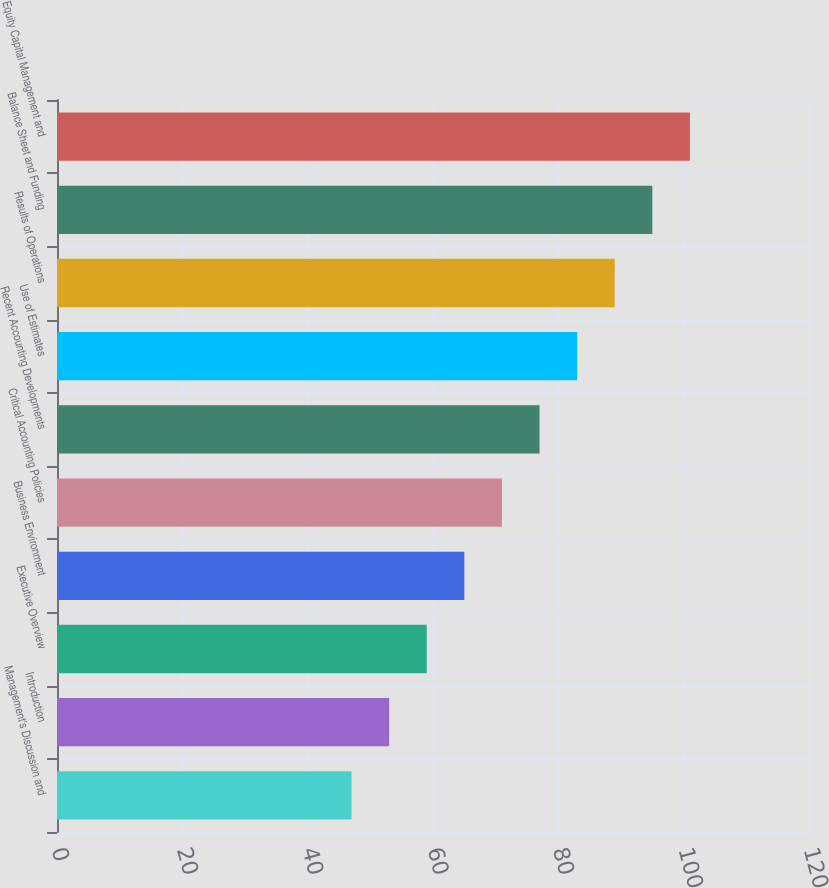<chart> <loc_0><loc_0><loc_500><loc_500><bar_chart><fcel>Management's Discussion and<fcel>Introduction<fcel>Executive Overview<fcel>Business Environment<fcel>Critical Accounting Policies<fcel>Recent Accounting Developments<fcel>Use of Estimates<fcel>Results of Operations<fcel>Balance Sheet and Funding<fcel>Equity Capital Management and<nl><fcel>47<fcel>53<fcel>59<fcel>65<fcel>71<fcel>77<fcel>83<fcel>89<fcel>95<fcel>101<nl></chart> 